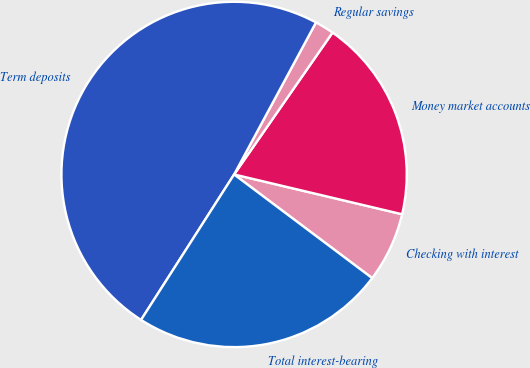Convert chart. <chart><loc_0><loc_0><loc_500><loc_500><pie_chart><fcel>Checking with interest<fcel>Money market accounts<fcel>Regular savings<fcel>Term deposits<fcel>Total interest-bearing<nl><fcel>6.55%<fcel>19.05%<fcel>1.79%<fcel>48.81%<fcel>23.81%<nl></chart> 